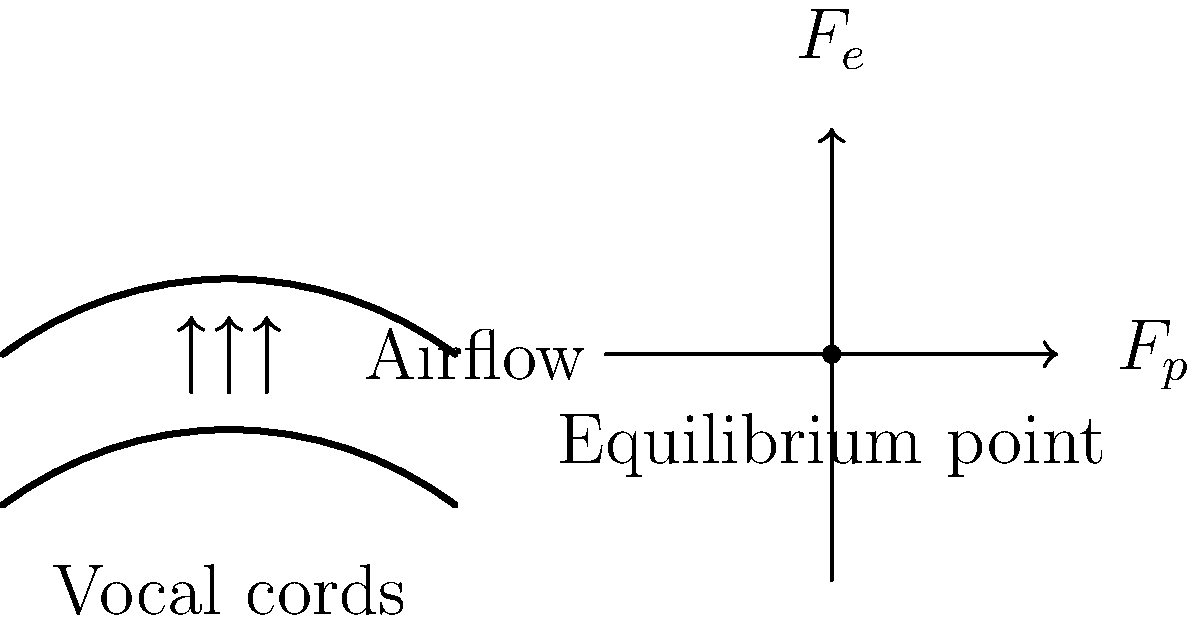As an aspiring Kpop idol, you're curious about the mechanics behind your vocal performance. Consider the diagram showing a simplified model of vocal cord vibration. The vocal cords are represented by the two curved lines, and the arrows indicate airflow. If the pressure force ($F_p$) acting on the vocal cords is 0.05 N and the elastic restoring force ($F_e$) is given by the equation $F_e = kx$, where $k = 100$ N/m and $x$ is the displacement from equilibrium, what is the maximum displacement of the vocal cords during vibration? To find the maximum displacement of the vocal cords, we need to consider the forces acting on them at the point of maximum displacement. At this point, the pressure force and the elastic restoring force are in equilibrium.

Step 1: Set up the force balance equation.
At maximum displacement: $F_p = F_e$

Step 2: Substitute the given values and equations.
$0.05 \text{ N} = kx = 100 \text{ N/m} \cdot x$

Step 3: Solve for x (displacement).
$x = \frac{0.05 \text{ N}}{100 \text{ N/m}} = 0.0005 \text{ m} = 0.5 \text{ mm}$

This result represents the maximum displacement of the vocal cords from their equilibrium position during vibration. Understanding this concept can help you visualize how your vocal cords move while singing, potentially improving your technique and vocal health awareness.
Answer: 0.5 mm 